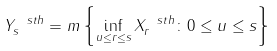<formula> <loc_0><loc_0><loc_500><loc_500>Y ^ { \ s t h } _ { s } = m \left \{ \inf _ { u \leq r \leq s } X ^ { \ s t h } _ { r } \colon 0 \leq u \leq s \right \}</formula> 